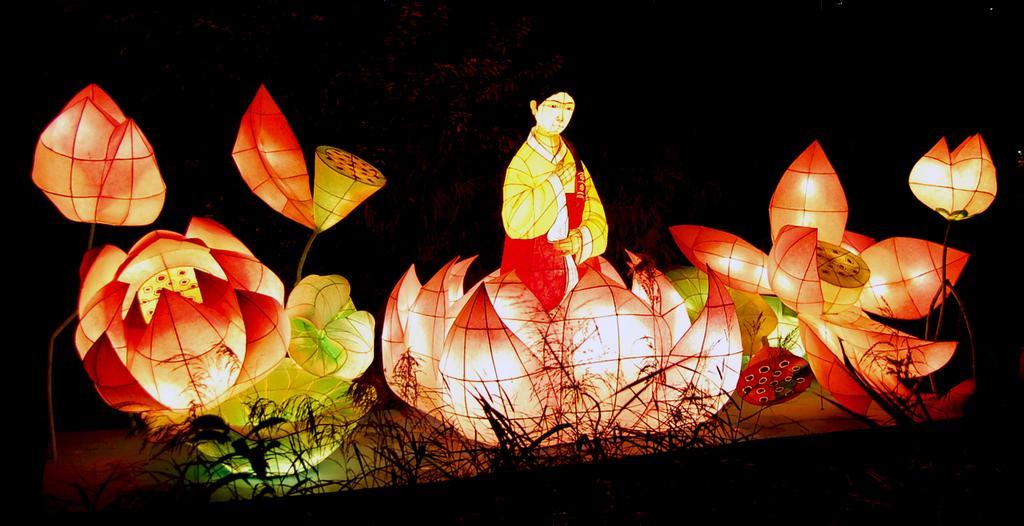Can you describe this image briefly? In this picture we can see colorful designs. Here we can see woman who is sitting on this lotus. On this plastic design we can see lights. On the bottom we can see plants. 